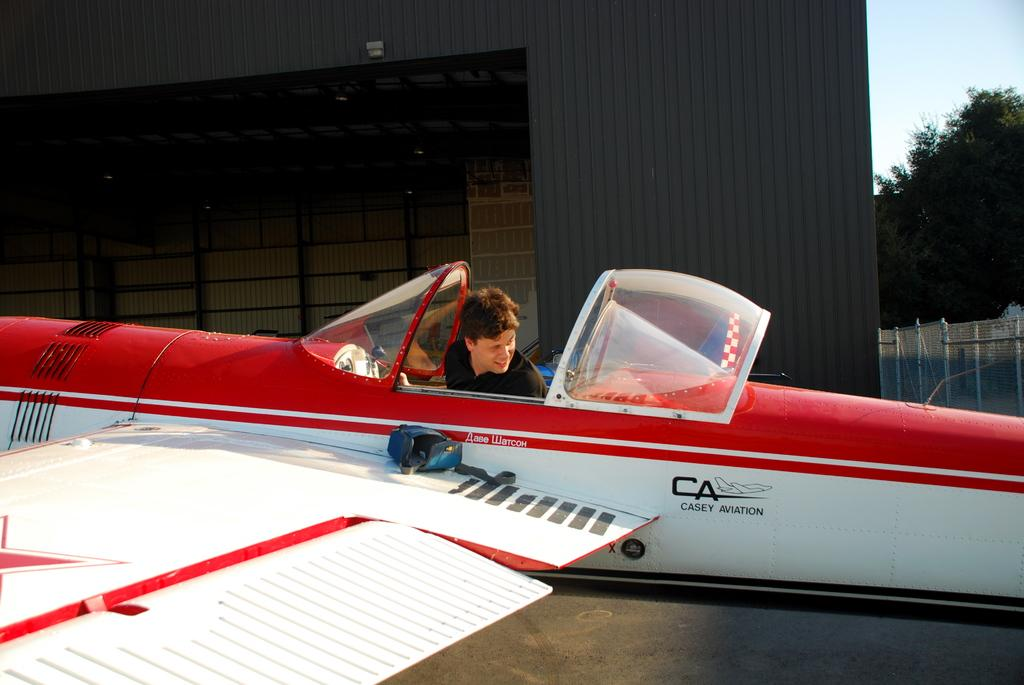Provide a one-sentence caption for the provided image. A man is sitting in a small white airplane that says Casey Aviation. 